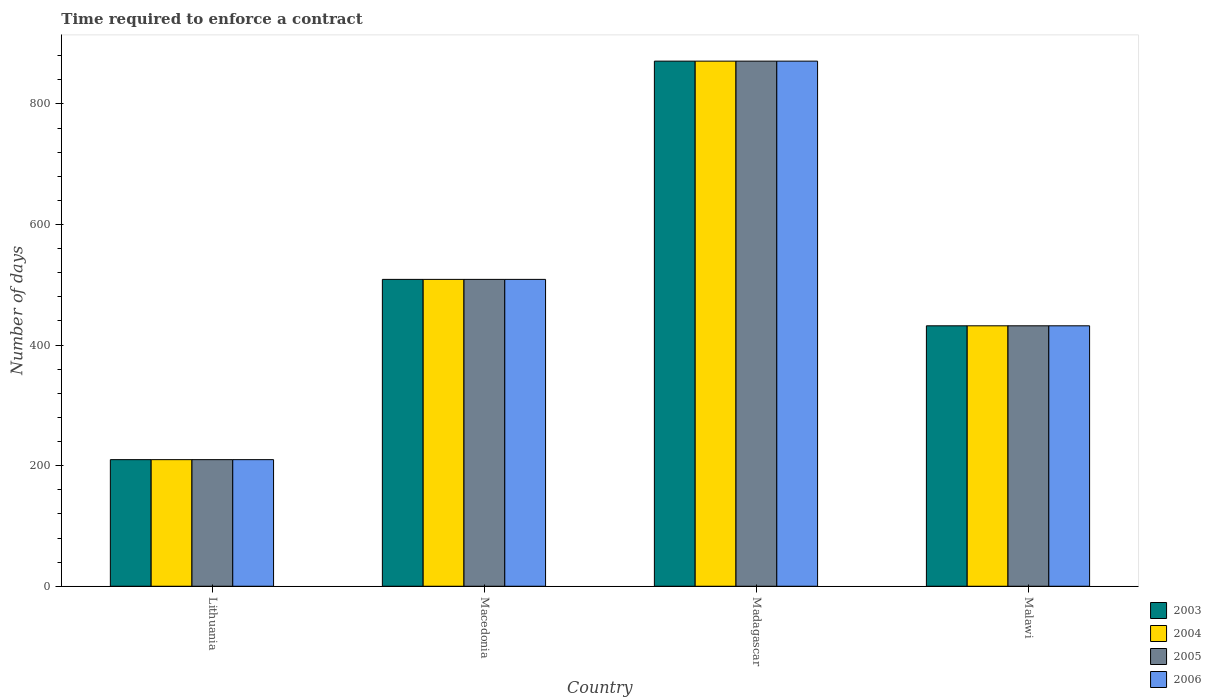How many groups of bars are there?
Your answer should be very brief. 4. Are the number of bars per tick equal to the number of legend labels?
Offer a very short reply. Yes. Are the number of bars on each tick of the X-axis equal?
Offer a terse response. Yes. How many bars are there on the 4th tick from the left?
Make the answer very short. 4. How many bars are there on the 2nd tick from the right?
Your answer should be very brief. 4. What is the label of the 1st group of bars from the left?
Provide a short and direct response. Lithuania. What is the number of days required to enforce a contract in 2006 in Madagascar?
Your answer should be compact. 871. Across all countries, what is the maximum number of days required to enforce a contract in 2003?
Your answer should be very brief. 871. Across all countries, what is the minimum number of days required to enforce a contract in 2003?
Ensure brevity in your answer.  210. In which country was the number of days required to enforce a contract in 2004 maximum?
Offer a terse response. Madagascar. In which country was the number of days required to enforce a contract in 2003 minimum?
Your response must be concise. Lithuania. What is the total number of days required to enforce a contract in 2005 in the graph?
Ensure brevity in your answer.  2022. What is the difference between the number of days required to enforce a contract in 2005 in Macedonia and that in Madagascar?
Offer a very short reply. -362. What is the difference between the number of days required to enforce a contract in 2004 in Macedonia and the number of days required to enforce a contract in 2005 in Madagascar?
Your response must be concise. -362. What is the average number of days required to enforce a contract in 2003 per country?
Provide a short and direct response. 505.5. In how many countries, is the number of days required to enforce a contract in 2005 greater than 480 days?
Keep it short and to the point. 2. What is the ratio of the number of days required to enforce a contract in 2006 in Lithuania to that in Malawi?
Make the answer very short. 0.49. Is the difference between the number of days required to enforce a contract in 2004 in Macedonia and Madagascar greater than the difference between the number of days required to enforce a contract in 2005 in Macedonia and Madagascar?
Ensure brevity in your answer.  No. What is the difference between the highest and the second highest number of days required to enforce a contract in 2005?
Your answer should be compact. -77. What is the difference between the highest and the lowest number of days required to enforce a contract in 2003?
Make the answer very short. 661. Is it the case that in every country, the sum of the number of days required to enforce a contract in 2006 and number of days required to enforce a contract in 2003 is greater than the sum of number of days required to enforce a contract in 2005 and number of days required to enforce a contract in 2004?
Your answer should be compact. No. How many bars are there?
Keep it short and to the point. 16. How many countries are there in the graph?
Offer a terse response. 4. Are the values on the major ticks of Y-axis written in scientific E-notation?
Your response must be concise. No. Where does the legend appear in the graph?
Provide a short and direct response. Bottom right. What is the title of the graph?
Ensure brevity in your answer.  Time required to enforce a contract. Does "2005" appear as one of the legend labels in the graph?
Give a very brief answer. Yes. What is the label or title of the Y-axis?
Give a very brief answer. Number of days. What is the Number of days of 2003 in Lithuania?
Give a very brief answer. 210. What is the Number of days of 2004 in Lithuania?
Ensure brevity in your answer.  210. What is the Number of days in 2005 in Lithuania?
Offer a very short reply. 210. What is the Number of days in 2006 in Lithuania?
Offer a terse response. 210. What is the Number of days of 2003 in Macedonia?
Your response must be concise. 509. What is the Number of days of 2004 in Macedonia?
Provide a short and direct response. 509. What is the Number of days in 2005 in Macedonia?
Provide a short and direct response. 509. What is the Number of days in 2006 in Macedonia?
Offer a very short reply. 509. What is the Number of days of 2003 in Madagascar?
Keep it short and to the point. 871. What is the Number of days of 2004 in Madagascar?
Provide a short and direct response. 871. What is the Number of days of 2005 in Madagascar?
Offer a very short reply. 871. What is the Number of days of 2006 in Madagascar?
Offer a very short reply. 871. What is the Number of days of 2003 in Malawi?
Offer a terse response. 432. What is the Number of days in 2004 in Malawi?
Make the answer very short. 432. What is the Number of days of 2005 in Malawi?
Give a very brief answer. 432. What is the Number of days in 2006 in Malawi?
Your answer should be very brief. 432. Across all countries, what is the maximum Number of days in 2003?
Provide a succinct answer. 871. Across all countries, what is the maximum Number of days in 2004?
Give a very brief answer. 871. Across all countries, what is the maximum Number of days in 2005?
Make the answer very short. 871. Across all countries, what is the maximum Number of days of 2006?
Make the answer very short. 871. Across all countries, what is the minimum Number of days of 2003?
Make the answer very short. 210. Across all countries, what is the minimum Number of days of 2004?
Offer a terse response. 210. Across all countries, what is the minimum Number of days of 2005?
Ensure brevity in your answer.  210. Across all countries, what is the minimum Number of days of 2006?
Provide a short and direct response. 210. What is the total Number of days of 2003 in the graph?
Offer a very short reply. 2022. What is the total Number of days in 2004 in the graph?
Offer a very short reply. 2022. What is the total Number of days in 2005 in the graph?
Make the answer very short. 2022. What is the total Number of days in 2006 in the graph?
Offer a very short reply. 2022. What is the difference between the Number of days of 2003 in Lithuania and that in Macedonia?
Offer a very short reply. -299. What is the difference between the Number of days in 2004 in Lithuania and that in Macedonia?
Ensure brevity in your answer.  -299. What is the difference between the Number of days of 2005 in Lithuania and that in Macedonia?
Offer a terse response. -299. What is the difference between the Number of days in 2006 in Lithuania and that in Macedonia?
Your answer should be very brief. -299. What is the difference between the Number of days of 2003 in Lithuania and that in Madagascar?
Your answer should be very brief. -661. What is the difference between the Number of days of 2004 in Lithuania and that in Madagascar?
Keep it short and to the point. -661. What is the difference between the Number of days of 2005 in Lithuania and that in Madagascar?
Keep it short and to the point. -661. What is the difference between the Number of days in 2006 in Lithuania and that in Madagascar?
Offer a terse response. -661. What is the difference between the Number of days in 2003 in Lithuania and that in Malawi?
Offer a very short reply. -222. What is the difference between the Number of days of 2004 in Lithuania and that in Malawi?
Offer a very short reply. -222. What is the difference between the Number of days in 2005 in Lithuania and that in Malawi?
Keep it short and to the point. -222. What is the difference between the Number of days in 2006 in Lithuania and that in Malawi?
Offer a very short reply. -222. What is the difference between the Number of days in 2003 in Macedonia and that in Madagascar?
Offer a terse response. -362. What is the difference between the Number of days of 2004 in Macedonia and that in Madagascar?
Ensure brevity in your answer.  -362. What is the difference between the Number of days in 2005 in Macedonia and that in Madagascar?
Give a very brief answer. -362. What is the difference between the Number of days in 2006 in Macedonia and that in Madagascar?
Provide a short and direct response. -362. What is the difference between the Number of days of 2003 in Macedonia and that in Malawi?
Provide a short and direct response. 77. What is the difference between the Number of days of 2006 in Macedonia and that in Malawi?
Make the answer very short. 77. What is the difference between the Number of days of 2003 in Madagascar and that in Malawi?
Your answer should be very brief. 439. What is the difference between the Number of days of 2004 in Madagascar and that in Malawi?
Your answer should be very brief. 439. What is the difference between the Number of days of 2005 in Madagascar and that in Malawi?
Your answer should be very brief. 439. What is the difference between the Number of days in 2006 in Madagascar and that in Malawi?
Your answer should be very brief. 439. What is the difference between the Number of days of 2003 in Lithuania and the Number of days of 2004 in Macedonia?
Give a very brief answer. -299. What is the difference between the Number of days of 2003 in Lithuania and the Number of days of 2005 in Macedonia?
Keep it short and to the point. -299. What is the difference between the Number of days of 2003 in Lithuania and the Number of days of 2006 in Macedonia?
Ensure brevity in your answer.  -299. What is the difference between the Number of days of 2004 in Lithuania and the Number of days of 2005 in Macedonia?
Provide a short and direct response. -299. What is the difference between the Number of days of 2004 in Lithuania and the Number of days of 2006 in Macedonia?
Provide a succinct answer. -299. What is the difference between the Number of days of 2005 in Lithuania and the Number of days of 2006 in Macedonia?
Make the answer very short. -299. What is the difference between the Number of days in 2003 in Lithuania and the Number of days in 2004 in Madagascar?
Provide a short and direct response. -661. What is the difference between the Number of days of 2003 in Lithuania and the Number of days of 2005 in Madagascar?
Give a very brief answer. -661. What is the difference between the Number of days of 2003 in Lithuania and the Number of days of 2006 in Madagascar?
Keep it short and to the point. -661. What is the difference between the Number of days in 2004 in Lithuania and the Number of days in 2005 in Madagascar?
Your answer should be very brief. -661. What is the difference between the Number of days in 2004 in Lithuania and the Number of days in 2006 in Madagascar?
Give a very brief answer. -661. What is the difference between the Number of days in 2005 in Lithuania and the Number of days in 2006 in Madagascar?
Keep it short and to the point. -661. What is the difference between the Number of days in 2003 in Lithuania and the Number of days in 2004 in Malawi?
Provide a succinct answer. -222. What is the difference between the Number of days of 2003 in Lithuania and the Number of days of 2005 in Malawi?
Your response must be concise. -222. What is the difference between the Number of days of 2003 in Lithuania and the Number of days of 2006 in Malawi?
Keep it short and to the point. -222. What is the difference between the Number of days of 2004 in Lithuania and the Number of days of 2005 in Malawi?
Offer a terse response. -222. What is the difference between the Number of days in 2004 in Lithuania and the Number of days in 2006 in Malawi?
Provide a short and direct response. -222. What is the difference between the Number of days in 2005 in Lithuania and the Number of days in 2006 in Malawi?
Keep it short and to the point. -222. What is the difference between the Number of days in 2003 in Macedonia and the Number of days in 2004 in Madagascar?
Offer a very short reply. -362. What is the difference between the Number of days of 2003 in Macedonia and the Number of days of 2005 in Madagascar?
Provide a short and direct response. -362. What is the difference between the Number of days of 2003 in Macedonia and the Number of days of 2006 in Madagascar?
Keep it short and to the point. -362. What is the difference between the Number of days of 2004 in Macedonia and the Number of days of 2005 in Madagascar?
Offer a terse response. -362. What is the difference between the Number of days in 2004 in Macedonia and the Number of days in 2006 in Madagascar?
Offer a terse response. -362. What is the difference between the Number of days in 2005 in Macedonia and the Number of days in 2006 in Madagascar?
Your answer should be compact. -362. What is the difference between the Number of days of 2003 in Macedonia and the Number of days of 2004 in Malawi?
Your answer should be very brief. 77. What is the difference between the Number of days in 2003 in Macedonia and the Number of days in 2005 in Malawi?
Ensure brevity in your answer.  77. What is the difference between the Number of days in 2005 in Macedonia and the Number of days in 2006 in Malawi?
Keep it short and to the point. 77. What is the difference between the Number of days of 2003 in Madagascar and the Number of days of 2004 in Malawi?
Ensure brevity in your answer.  439. What is the difference between the Number of days in 2003 in Madagascar and the Number of days in 2005 in Malawi?
Ensure brevity in your answer.  439. What is the difference between the Number of days of 2003 in Madagascar and the Number of days of 2006 in Malawi?
Provide a succinct answer. 439. What is the difference between the Number of days in 2004 in Madagascar and the Number of days in 2005 in Malawi?
Offer a terse response. 439. What is the difference between the Number of days in 2004 in Madagascar and the Number of days in 2006 in Malawi?
Keep it short and to the point. 439. What is the difference between the Number of days in 2005 in Madagascar and the Number of days in 2006 in Malawi?
Your answer should be very brief. 439. What is the average Number of days of 2003 per country?
Offer a very short reply. 505.5. What is the average Number of days of 2004 per country?
Offer a terse response. 505.5. What is the average Number of days of 2005 per country?
Provide a succinct answer. 505.5. What is the average Number of days in 2006 per country?
Provide a short and direct response. 505.5. What is the difference between the Number of days in 2003 and Number of days in 2005 in Lithuania?
Provide a short and direct response. 0. What is the difference between the Number of days in 2003 and Number of days in 2006 in Lithuania?
Offer a terse response. 0. What is the difference between the Number of days in 2004 and Number of days in 2005 in Lithuania?
Your answer should be compact. 0. What is the difference between the Number of days of 2005 and Number of days of 2006 in Lithuania?
Give a very brief answer. 0. What is the difference between the Number of days in 2003 and Number of days in 2004 in Macedonia?
Provide a short and direct response. 0. What is the difference between the Number of days in 2004 and Number of days in 2006 in Macedonia?
Provide a succinct answer. 0. What is the difference between the Number of days in 2005 and Number of days in 2006 in Macedonia?
Ensure brevity in your answer.  0. What is the difference between the Number of days in 2003 and Number of days in 2004 in Madagascar?
Keep it short and to the point. 0. What is the difference between the Number of days of 2004 and Number of days of 2005 in Madagascar?
Provide a succinct answer. 0. What is the difference between the Number of days in 2004 and Number of days in 2006 in Madagascar?
Provide a short and direct response. 0. What is the difference between the Number of days in 2005 and Number of days in 2006 in Madagascar?
Offer a very short reply. 0. What is the difference between the Number of days of 2003 and Number of days of 2004 in Malawi?
Ensure brevity in your answer.  0. What is the difference between the Number of days of 2004 and Number of days of 2005 in Malawi?
Your answer should be compact. 0. What is the difference between the Number of days of 2004 and Number of days of 2006 in Malawi?
Make the answer very short. 0. What is the ratio of the Number of days in 2003 in Lithuania to that in Macedonia?
Offer a terse response. 0.41. What is the ratio of the Number of days of 2004 in Lithuania to that in Macedonia?
Your answer should be very brief. 0.41. What is the ratio of the Number of days of 2005 in Lithuania to that in Macedonia?
Ensure brevity in your answer.  0.41. What is the ratio of the Number of days of 2006 in Lithuania to that in Macedonia?
Your response must be concise. 0.41. What is the ratio of the Number of days in 2003 in Lithuania to that in Madagascar?
Keep it short and to the point. 0.24. What is the ratio of the Number of days of 2004 in Lithuania to that in Madagascar?
Offer a terse response. 0.24. What is the ratio of the Number of days in 2005 in Lithuania to that in Madagascar?
Offer a terse response. 0.24. What is the ratio of the Number of days of 2006 in Lithuania to that in Madagascar?
Offer a very short reply. 0.24. What is the ratio of the Number of days in 2003 in Lithuania to that in Malawi?
Offer a terse response. 0.49. What is the ratio of the Number of days of 2004 in Lithuania to that in Malawi?
Ensure brevity in your answer.  0.49. What is the ratio of the Number of days in 2005 in Lithuania to that in Malawi?
Your answer should be compact. 0.49. What is the ratio of the Number of days in 2006 in Lithuania to that in Malawi?
Give a very brief answer. 0.49. What is the ratio of the Number of days of 2003 in Macedonia to that in Madagascar?
Your response must be concise. 0.58. What is the ratio of the Number of days in 2004 in Macedonia to that in Madagascar?
Keep it short and to the point. 0.58. What is the ratio of the Number of days of 2005 in Macedonia to that in Madagascar?
Offer a terse response. 0.58. What is the ratio of the Number of days in 2006 in Macedonia to that in Madagascar?
Give a very brief answer. 0.58. What is the ratio of the Number of days of 2003 in Macedonia to that in Malawi?
Give a very brief answer. 1.18. What is the ratio of the Number of days in 2004 in Macedonia to that in Malawi?
Your answer should be compact. 1.18. What is the ratio of the Number of days of 2005 in Macedonia to that in Malawi?
Your answer should be very brief. 1.18. What is the ratio of the Number of days in 2006 in Macedonia to that in Malawi?
Provide a short and direct response. 1.18. What is the ratio of the Number of days in 2003 in Madagascar to that in Malawi?
Your response must be concise. 2.02. What is the ratio of the Number of days of 2004 in Madagascar to that in Malawi?
Provide a short and direct response. 2.02. What is the ratio of the Number of days of 2005 in Madagascar to that in Malawi?
Keep it short and to the point. 2.02. What is the ratio of the Number of days of 2006 in Madagascar to that in Malawi?
Ensure brevity in your answer.  2.02. What is the difference between the highest and the second highest Number of days in 2003?
Offer a terse response. 362. What is the difference between the highest and the second highest Number of days in 2004?
Provide a succinct answer. 362. What is the difference between the highest and the second highest Number of days in 2005?
Offer a very short reply. 362. What is the difference between the highest and the second highest Number of days of 2006?
Ensure brevity in your answer.  362. What is the difference between the highest and the lowest Number of days of 2003?
Keep it short and to the point. 661. What is the difference between the highest and the lowest Number of days in 2004?
Your answer should be very brief. 661. What is the difference between the highest and the lowest Number of days of 2005?
Give a very brief answer. 661. What is the difference between the highest and the lowest Number of days of 2006?
Offer a very short reply. 661. 